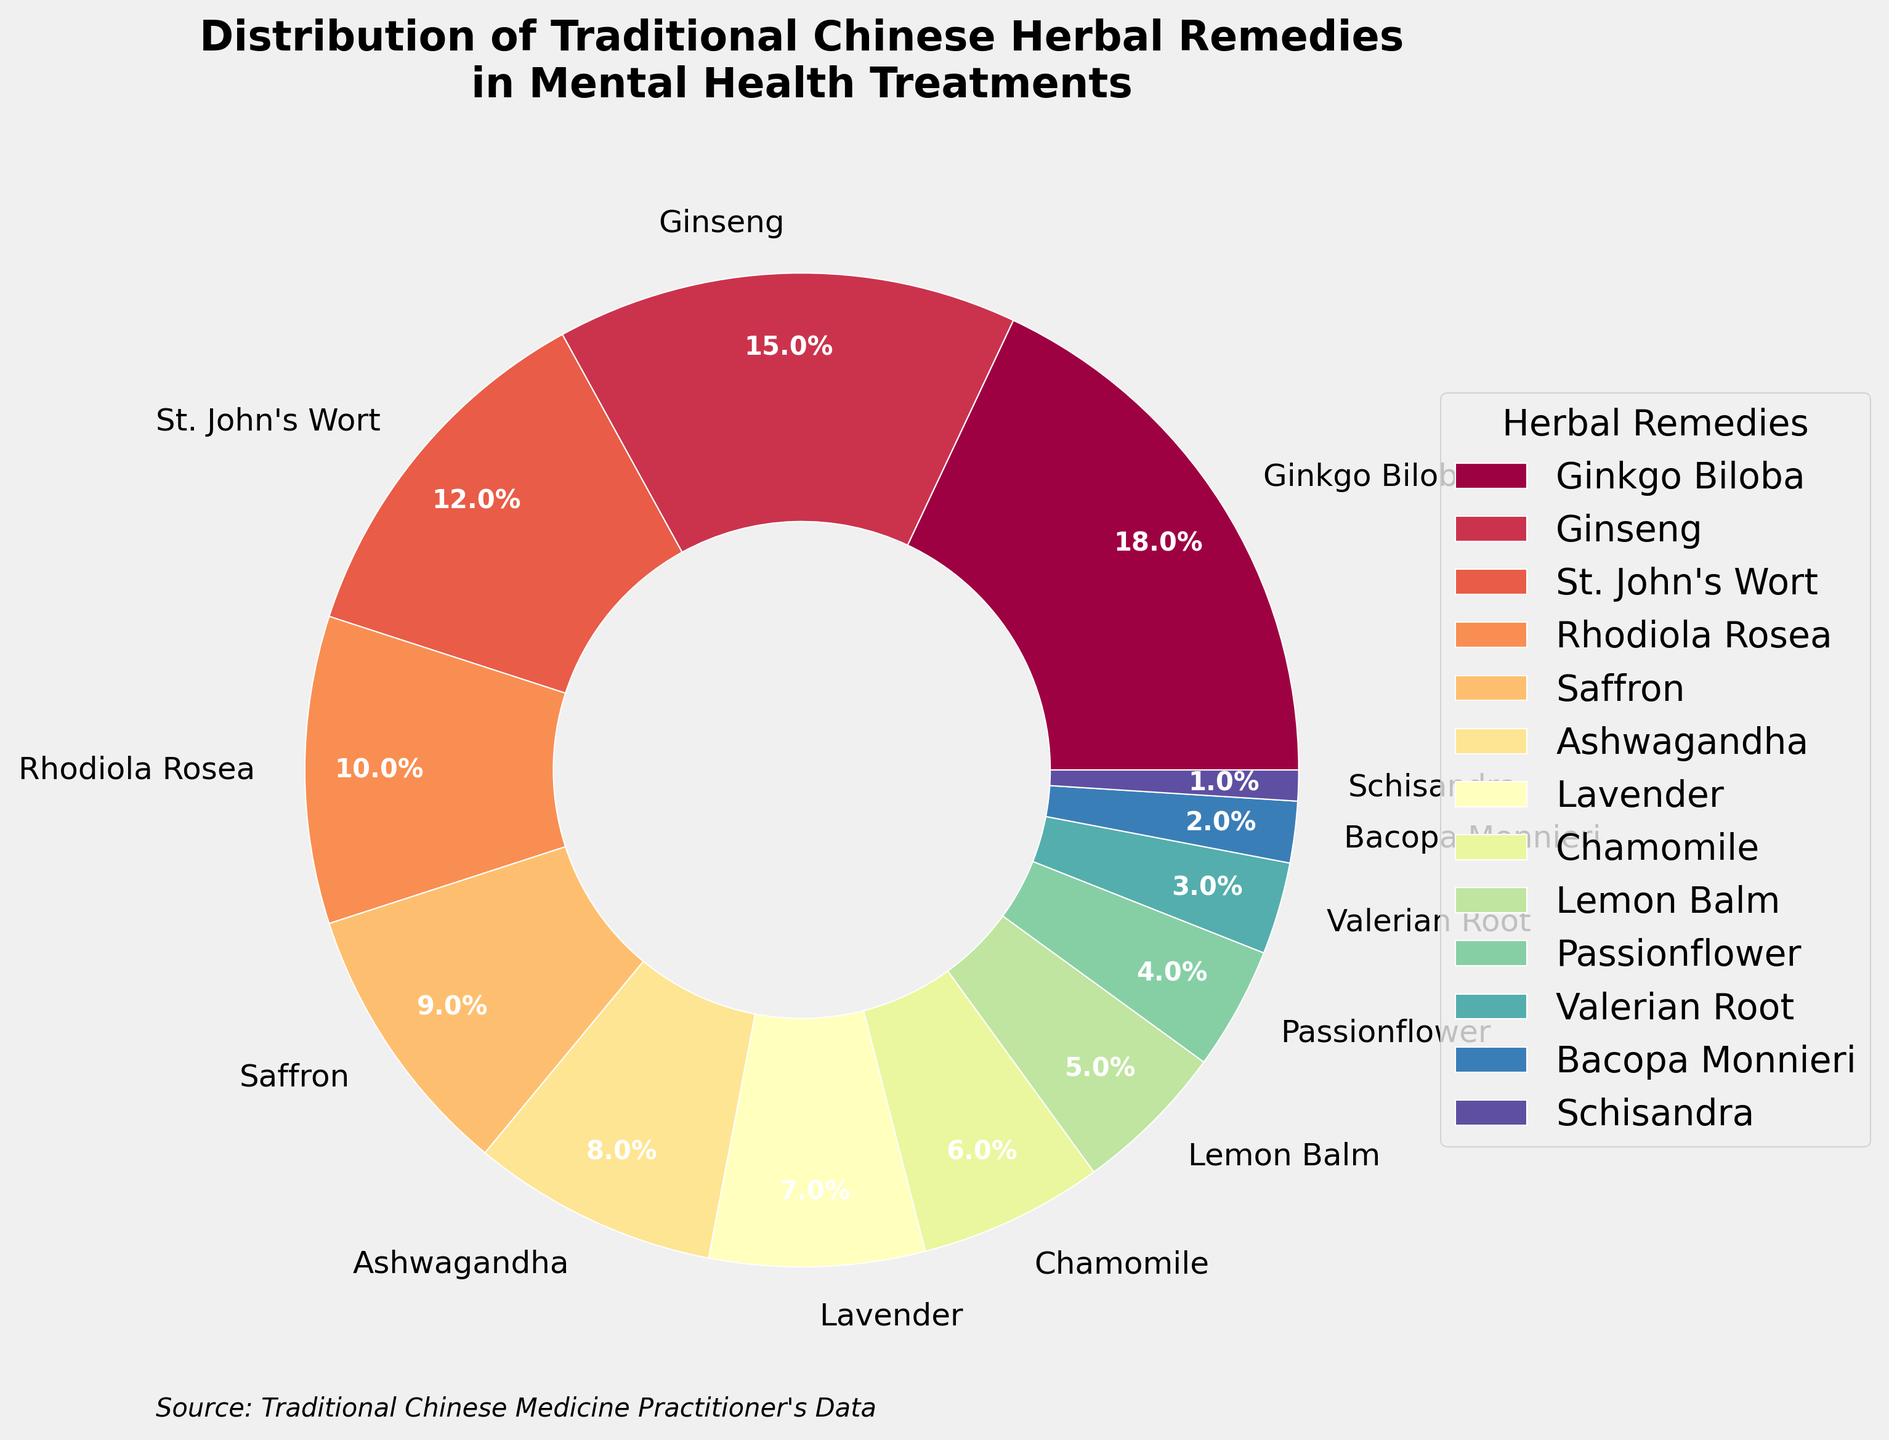What percentage of mental health treatments use Ginkgo Biloba and Ginseng combined? Sum the percentages of Ginkgo Biloba (18%) and Ginseng (15%). 18 + 15 = 33
Answer: 33% Which herbal remedy is less frequently used, St. John's Wort or Rhodiola Rosea? Compare the percentages: St. John's Wort (12%) and Rhodiola Rosea (10%). Rhodiola Rosea has a smaller percentage.
Answer: Rhodiola Rosea How many herbal remedies have a usage percentage greater than 10%? Identify remedies with more than 10%: Ginkgo Biloba (18%), Ginseng (15%), and St. John's Wort (12%). There are 3 such remedies.
Answer: 3 Which herbal remedy is represented by the smallest slice of the pie chart? Identify the remedy with the smallest percentage: Schisandra (1%).
Answer: Schisandra What is the difference in usage percentage between Ashwagandha and Lavender? Difference between Ashwagandha (8%) and Lavender (7%). 8 - 7 = 1
Answer: 1% Which herbal remedy's slice is larger, Lemon Balm or Chamomile? Compare the percentages: Lemon Balm (5%) and Chamomile (6%). Chamomile has a larger slice.
Answer: Chamomile What is the average percentage usage of Saffron, Ashwagandha, Lavender, and Chamomile? Calculate the average: (Saffron (9%) + Ashwagandha (8%) + Lavender (7%) + Chamomile (6%)) / 4 = 30 / 4 = 7.5
Answer: 7.5% Are there more herbal remedies used less than 5% or more than 10% in the treatments? Count the remedies: Less than 5%: 4 (Passionflower, Valerian Root, Bacopa Monnieri, Schisandra). More than 10%: 3 (Ginkgo Biloba, Ginseng, St. John's Wort). There are more remedies used less than 5%.
Answer: Less than 5% What is the visual representation color of Ginseng on the pie chart? Ginseng's slice is the second in the order in the legend and typically shown in the sequential color pattern which is a shade in the color spectrum starting from red. Exact color interpretation needs the chart.
Answer: Spectrum shade in sequence 